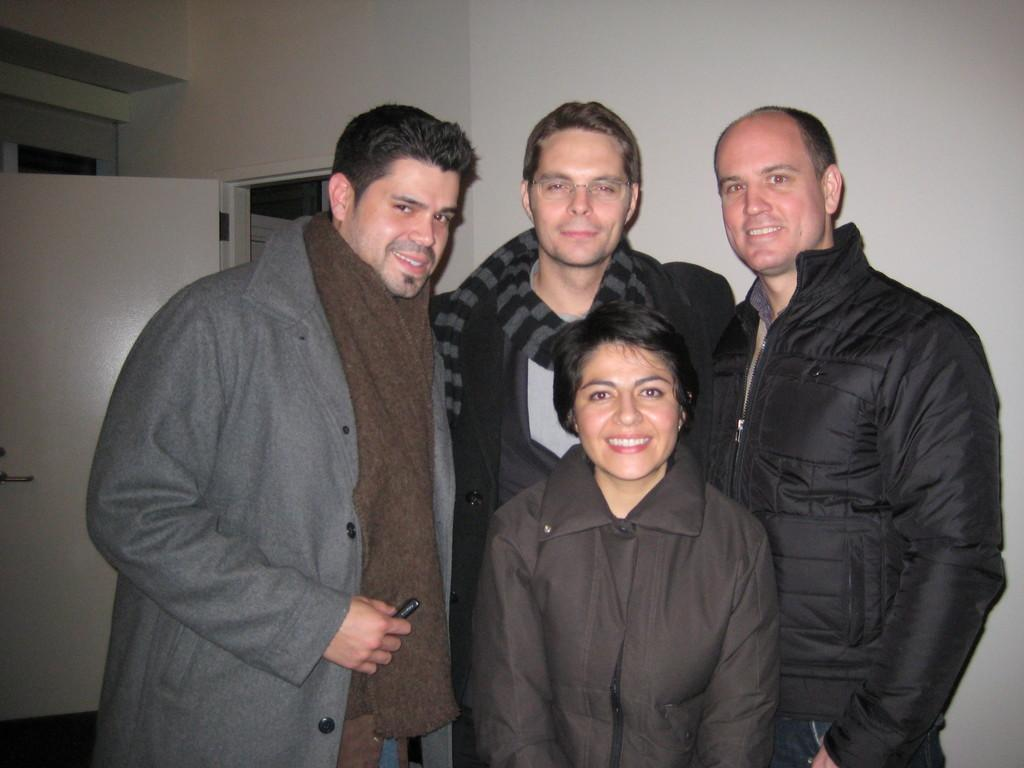How many people are in the image? There are three men and a woman in the image, making a total of four people. What are the people in the image doing? The people are standing and smiling in the image. What are the people wearing in the image? The people are wearing jackets in the image. What can be seen in the background of the image? There is a wall with a white door in the background of the image. What type of pancake is being served in the basket near the harbor in the image? There is no pancake, basket, or harbor present in the image. 